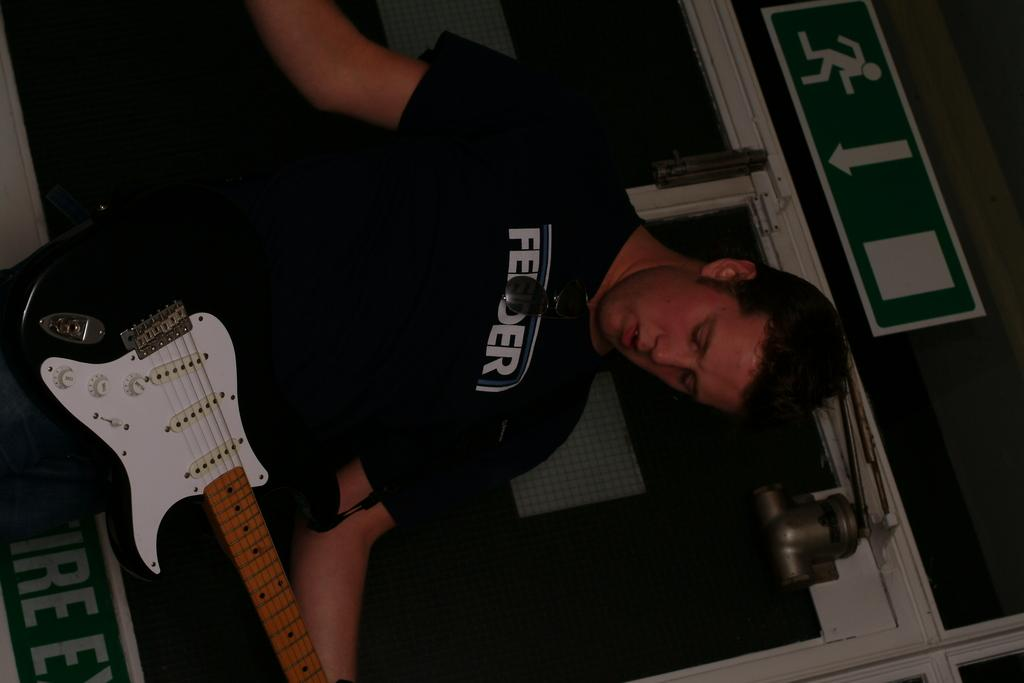What is the person in the image doing? The person is holding a guitar. What else can be seen in the image besides the person? There is a sign board and a window in the image. What type of eggnog is the person drinking in the image? There is no eggnog present in the image; the person is holding a guitar. Is the queen present in the image? There is no mention of a queen in the image; it features a person holding a guitar, a sign board, and a window. 